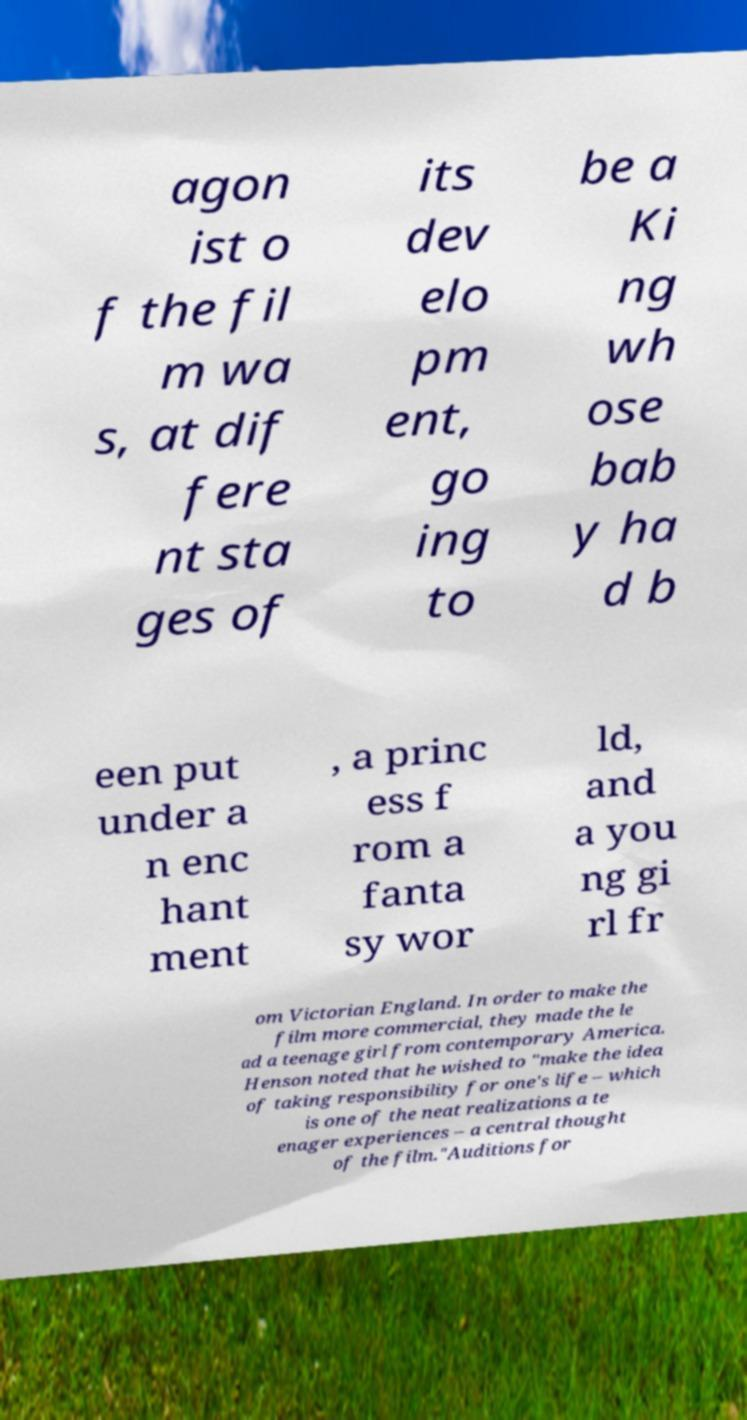What messages or text are displayed in this image? I need them in a readable, typed format. agon ist o f the fil m wa s, at dif fere nt sta ges of its dev elo pm ent, go ing to be a Ki ng wh ose bab y ha d b een put under a n enc hant ment , a princ ess f rom a fanta sy wor ld, and a you ng gi rl fr om Victorian England. In order to make the film more commercial, they made the le ad a teenage girl from contemporary America. Henson noted that he wished to "make the idea of taking responsibility for one's life – which is one of the neat realizations a te enager experiences – a central thought of the film."Auditions for 